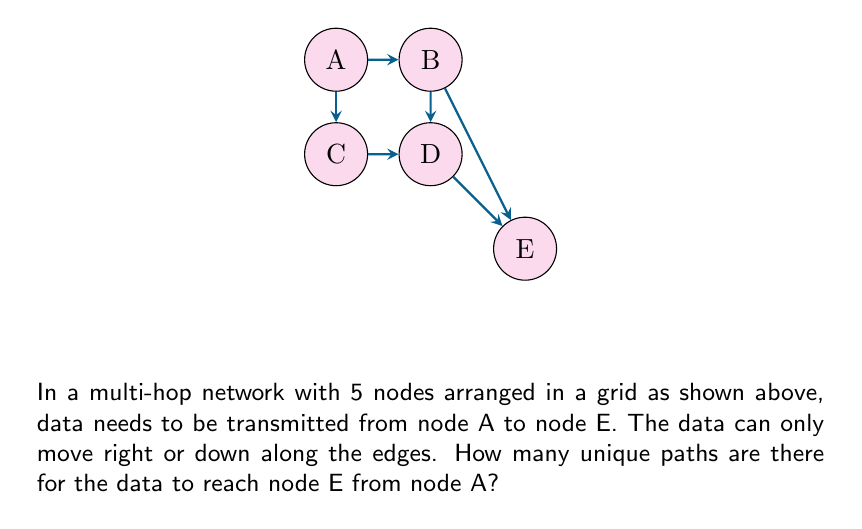Can you solve this math problem? Let's approach this step-by-step:

1) First, observe that to reach E from A, the data must always move 2 steps right and 2 steps down, regardless of the path taken.

2) This problem can be solved using combinatorics. Specifically, we need to calculate the number of ways to arrange 2 right moves and 2 down moves.

3) This is equivalent to choosing positions for the right moves (or down moves) out of the total 4 moves.

4) We can use the combination formula:

   $$C(n,r) = \frac{n!}{r!(n-r)!}$$

   Where $n$ is the total number of moves, and $r$ is the number of right (or down) moves.

5) In this case, $n = 4$ (total moves) and $r = 2$ (right moves or down moves).

6) Plugging into the formula:

   $$C(4,2) = \frac{4!}{2!(4-2)!} = \frac{4!}{2!2!}$$

7) Calculating:
   
   $$\frac{4 * 3 * 2 * 1}{(2 * 1)(2 * 1)} = \frac{24}{4} = 6$$

Therefore, there are 6 unique paths for the data to reach node E from node A.
Answer: 6 paths 